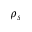<formula> <loc_0><loc_0><loc_500><loc_500>\rho _ { s }</formula> 